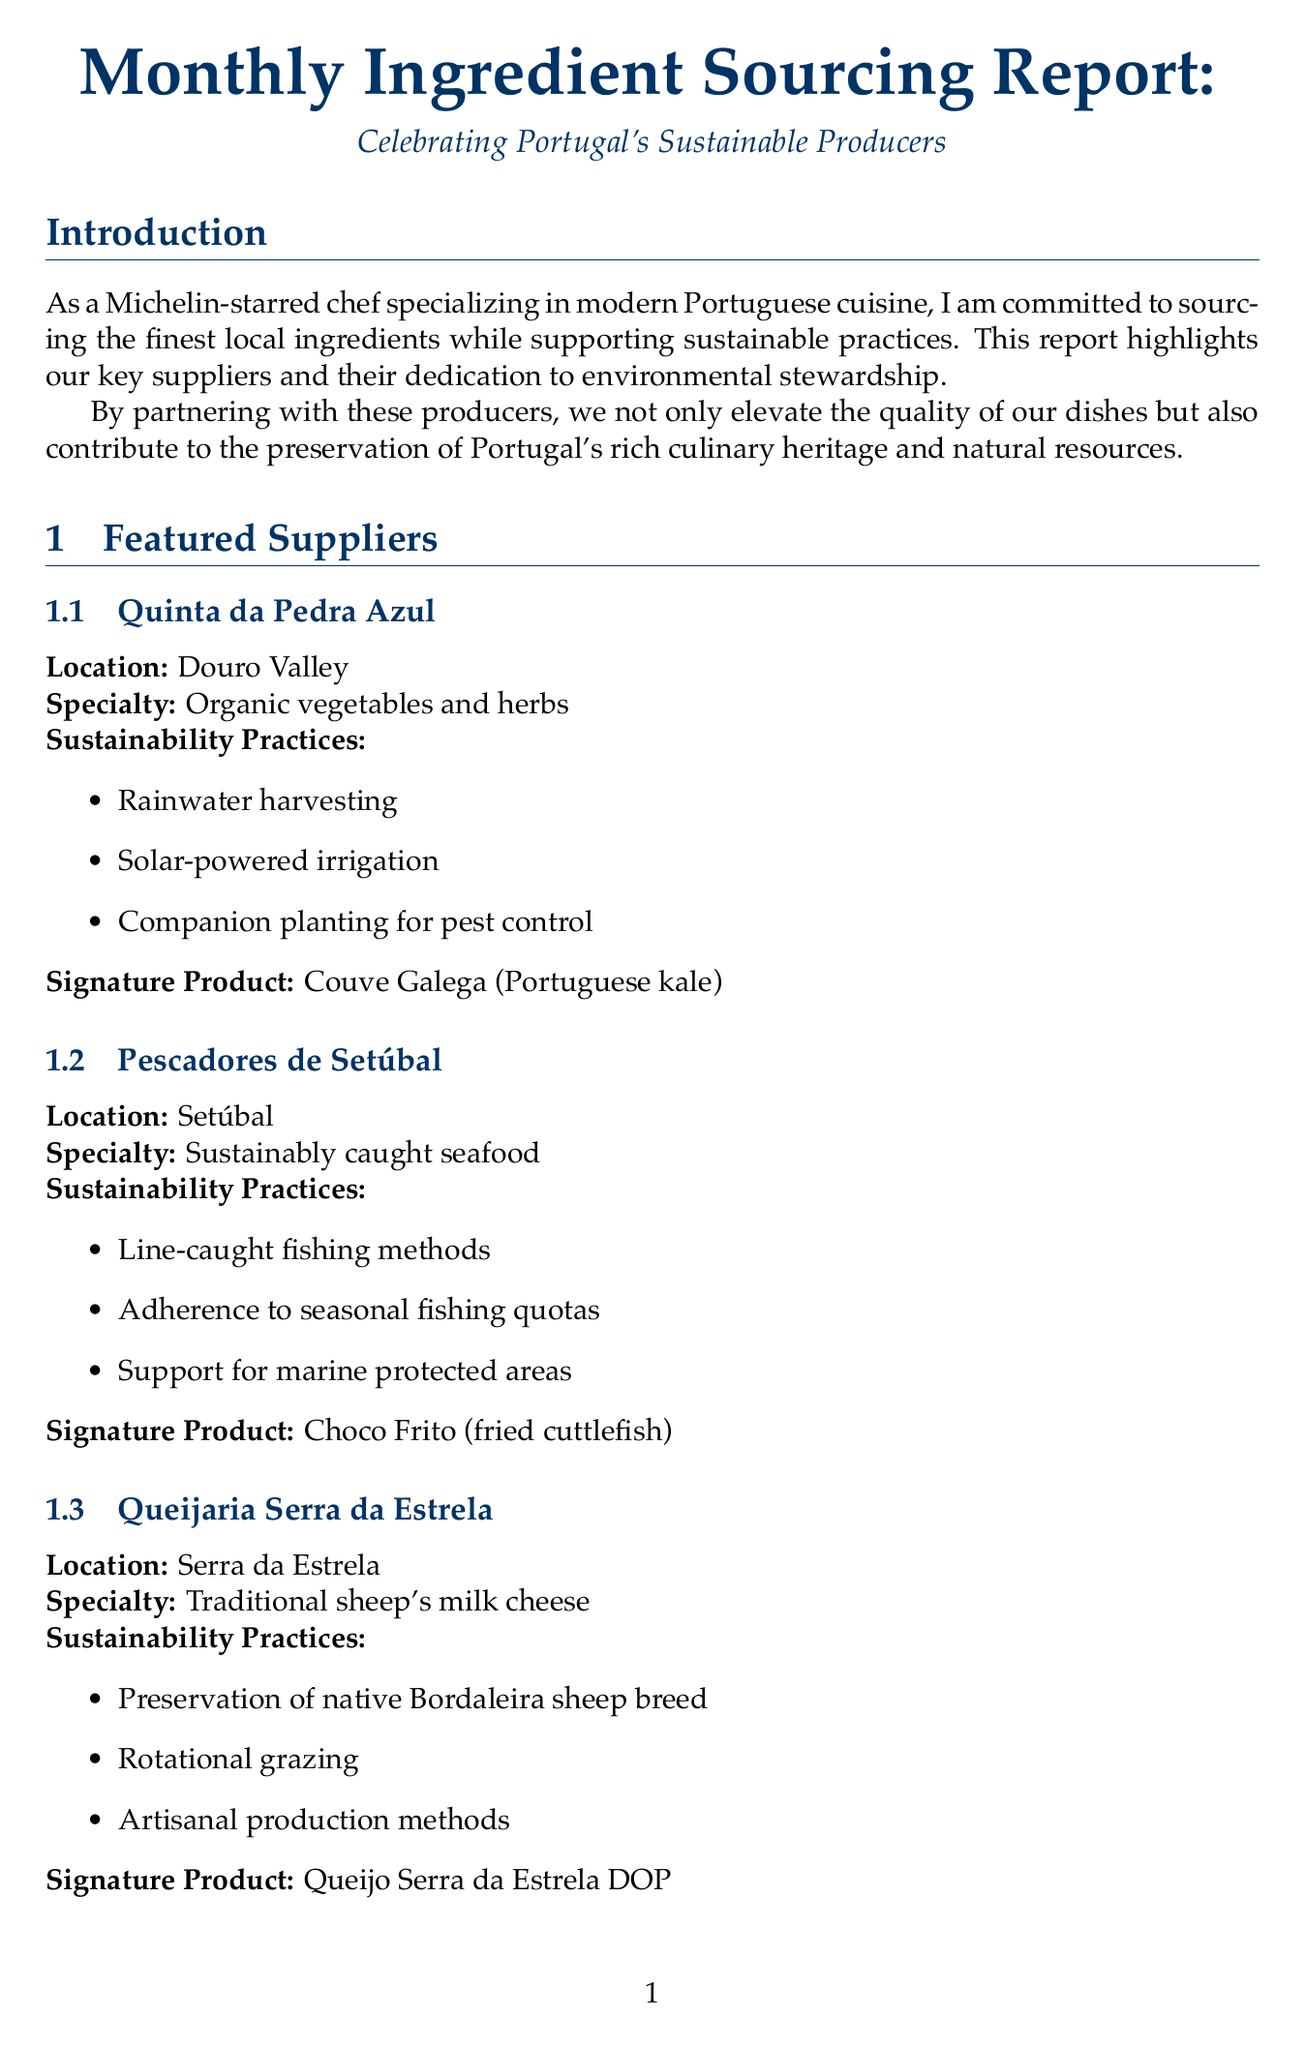What is the title of the report? The title of the report is explicitly stated at the beginning of the document.
Answer: Monthly Ingredient Sourcing Report: Celebrating Portugal's Sustainable Producers Where is Quinta da Pedra Azul located? The location of each featured supplier is mentioned in the respective sections.
Answer: Douro Valley What is the signature product of Pescadores de Setúbal? The signature product is specified in the supplier section, highlighting their offering.
Answer: Choco Frito (fried cuttlefish) What percentage of locally sourced ingredients is targeted in the short term? The document states the goal for locally sourced ingredients in the future goals section.
Answer: 90% Which sustainability practice is associated with Queijaria Serra da Estrela? The document lists multiple sustainability practices for each supplier.
Answer: Preservation of native Bordaleira sheep breed What type of cheese does Queijaria Serra da Estrela specialize in? Each featured supplier's specialty is highlighted in their respective sections.
Answer: Traditional sheep's milk cheese What is one initiative mentioned in the sustainability initiatives section? The document lists specific initiatives aimed at sustainability practices.
Answer: Zero Waste Kitchen What seasonal seafood is highlighted in the report? Seasonal highlights for different categories of food are provided in the document.
Answer: Line-caught sardines from Pescadores de Setúbal 